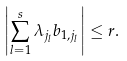<formula> <loc_0><loc_0><loc_500><loc_500>\left | \sum _ { l = 1 } ^ { s } \lambda _ { j _ { l } } b _ { 1 , j _ { l } } \right | \leq r .</formula> 